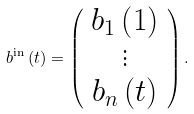Convert formula to latex. <formula><loc_0><loc_0><loc_500><loc_500>b ^ { \text {in} } \left ( t \right ) = \left ( \begin{array} { c } b _ { 1 } \left ( 1 \right ) \\ \vdots \\ b _ { n } \left ( t \right ) \end{array} \right ) .</formula> 